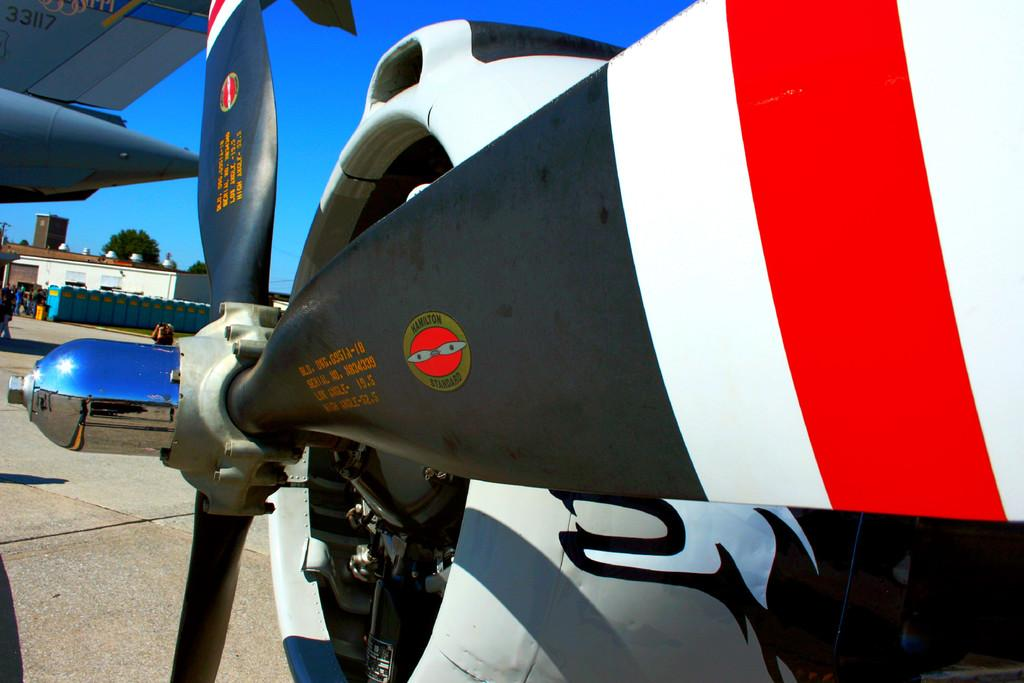What type of aircraft is partially visible in the image? There is a part of a monoplane in the image. What type of barrier can be seen in the image? There is a fence visible in the image. What type of vegetation is present in the image? There is a tree in the image. What type of structure is present in the image? There is a building in the image. What is the condition of the sky in the image? The sky is visible in the image and appears cloudy. How many cherries are hanging from the tree in the image? There are no cherries present in the image; it features a tree without any fruit. What is the limit of the fence in the image? The image does not provide information about the length or extent of the fence, so it is impossible to determine its limit. 